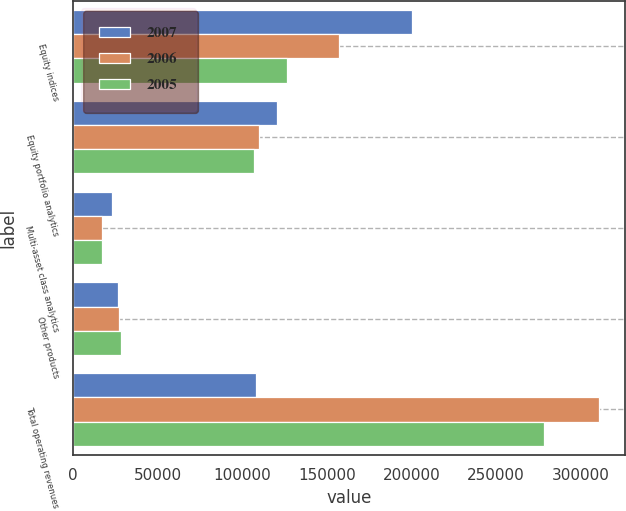Convert chart to OTSL. <chart><loc_0><loc_0><loc_500><loc_500><stacked_bar_chart><ecel><fcel>Equity indices<fcel>Equity portfolio analytics<fcel>Multi-asset class analytics<fcel>Other products<fcel>Total operating revenues<nl><fcel>2007<fcel>199992<fcel>120648<fcel>23071<fcel>26175<fcel>108300<nl><fcel>2006<fcel>156772<fcel>110007<fcel>16873<fcel>27046<fcel>310698<nl><fcel>2005<fcel>126533<fcel>106594<fcel>17260<fcel>28087<fcel>278474<nl></chart> 